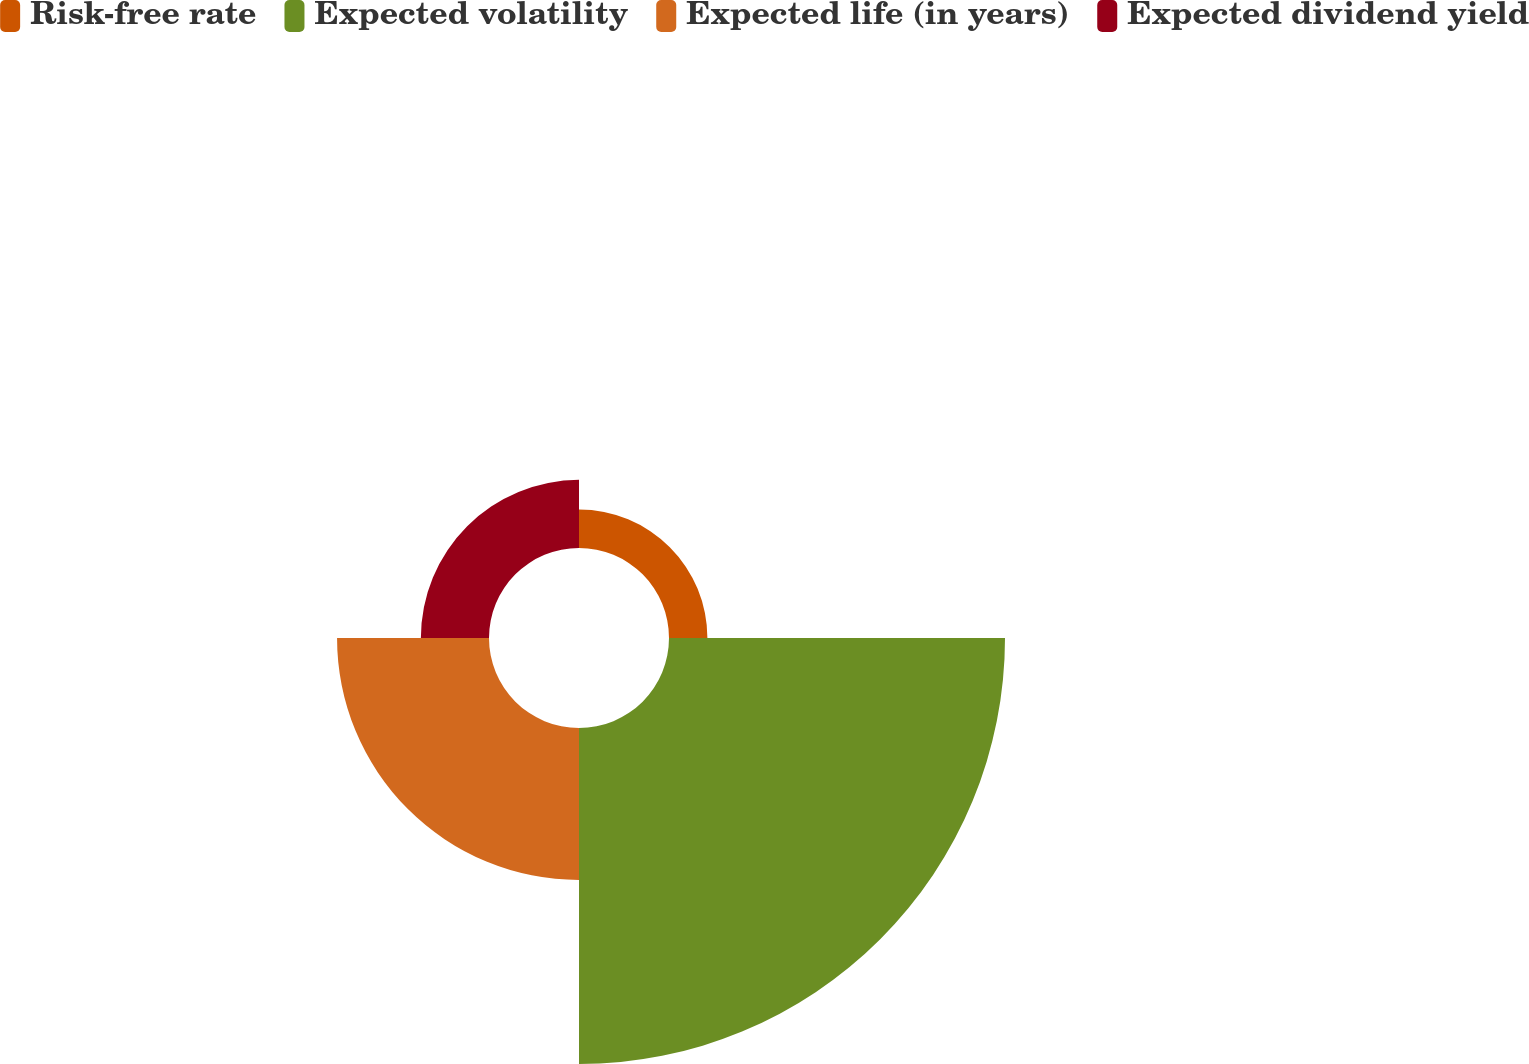<chart> <loc_0><loc_0><loc_500><loc_500><pie_chart><fcel>Risk-free rate<fcel>Expected volatility<fcel>Expected life (in years)<fcel>Expected dividend yield<nl><fcel>6.46%<fcel>56.52%<fcel>25.56%<fcel>11.46%<nl></chart> 